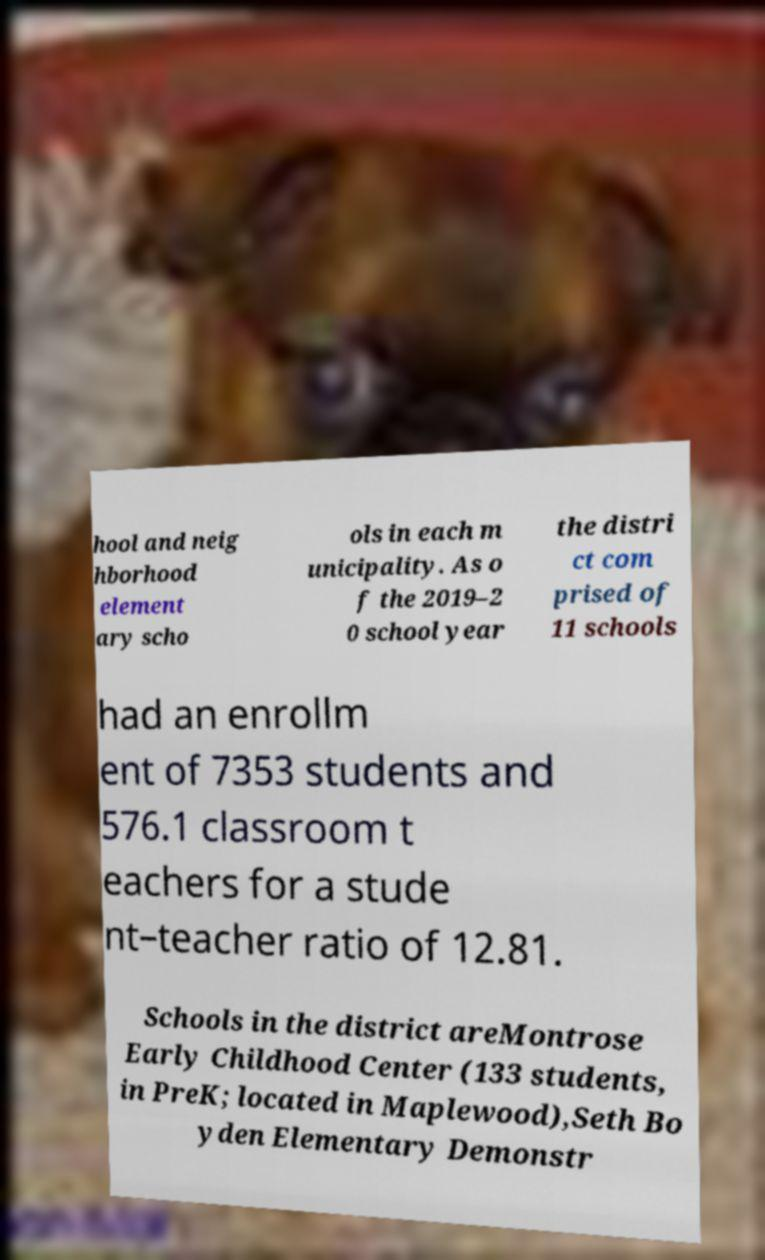I need the written content from this picture converted into text. Can you do that? hool and neig hborhood element ary scho ols in each m unicipality. As o f the 2019–2 0 school year the distri ct com prised of 11 schools had an enrollm ent of 7353 students and 576.1 classroom t eachers for a stude nt–teacher ratio of 12.81. Schools in the district areMontrose Early Childhood Center (133 students, in PreK; located in Maplewood),Seth Bo yden Elementary Demonstr 